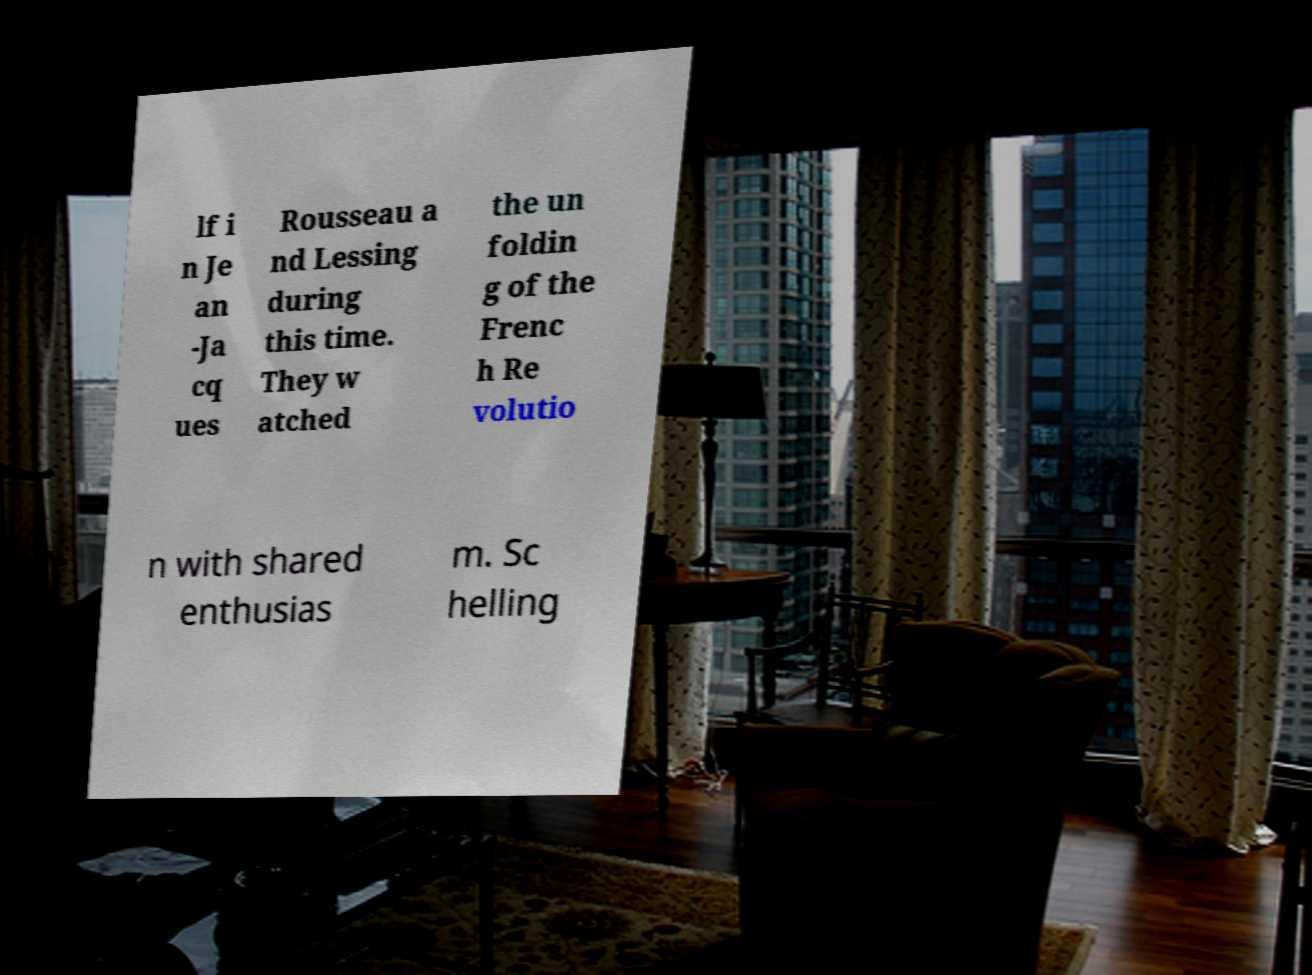Please read and relay the text visible in this image. What does it say? lf i n Je an -Ja cq ues Rousseau a nd Lessing during this time. They w atched the un foldin g of the Frenc h Re volutio n with shared enthusias m. Sc helling 